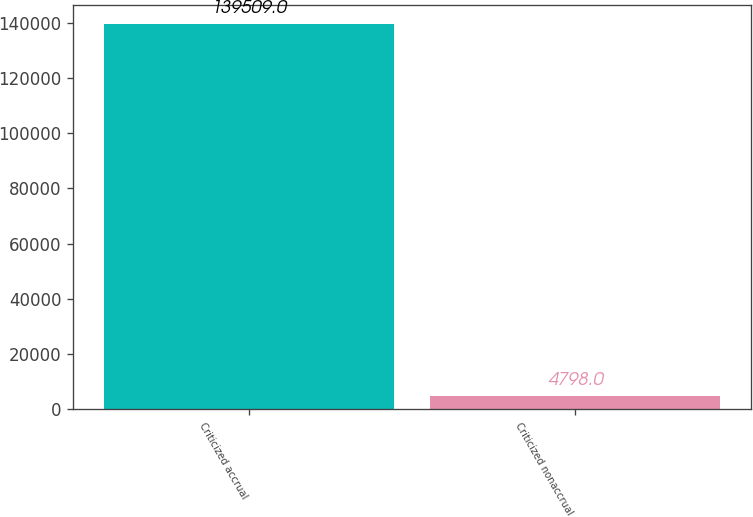Convert chart. <chart><loc_0><loc_0><loc_500><loc_500><bar_chart><fcel>Criticized accrual<fcel>Criticized nonaccrual<nl><fcel>139509<fcel>4798<nl></chart> 